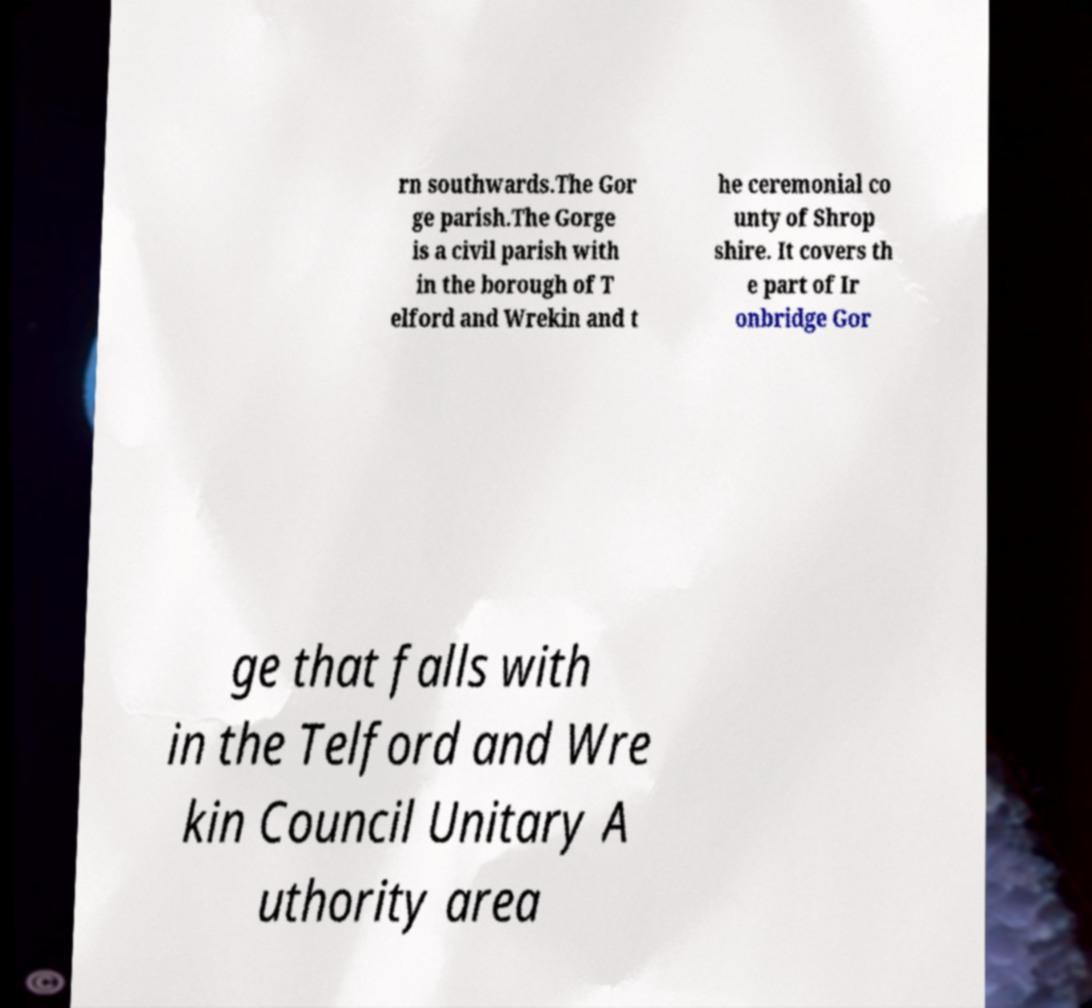Could you extract and type out the text from this image? rn southwards.The Gor ge parish.The Gorge is a civil parish with in the borough of T elford and Wrekin and t he ceremonial co unty of Shrop shire. It covers th e part of Ir onbridge Gor ge that falls with in the Telford and Wre kin Council Unitary A uthority area 